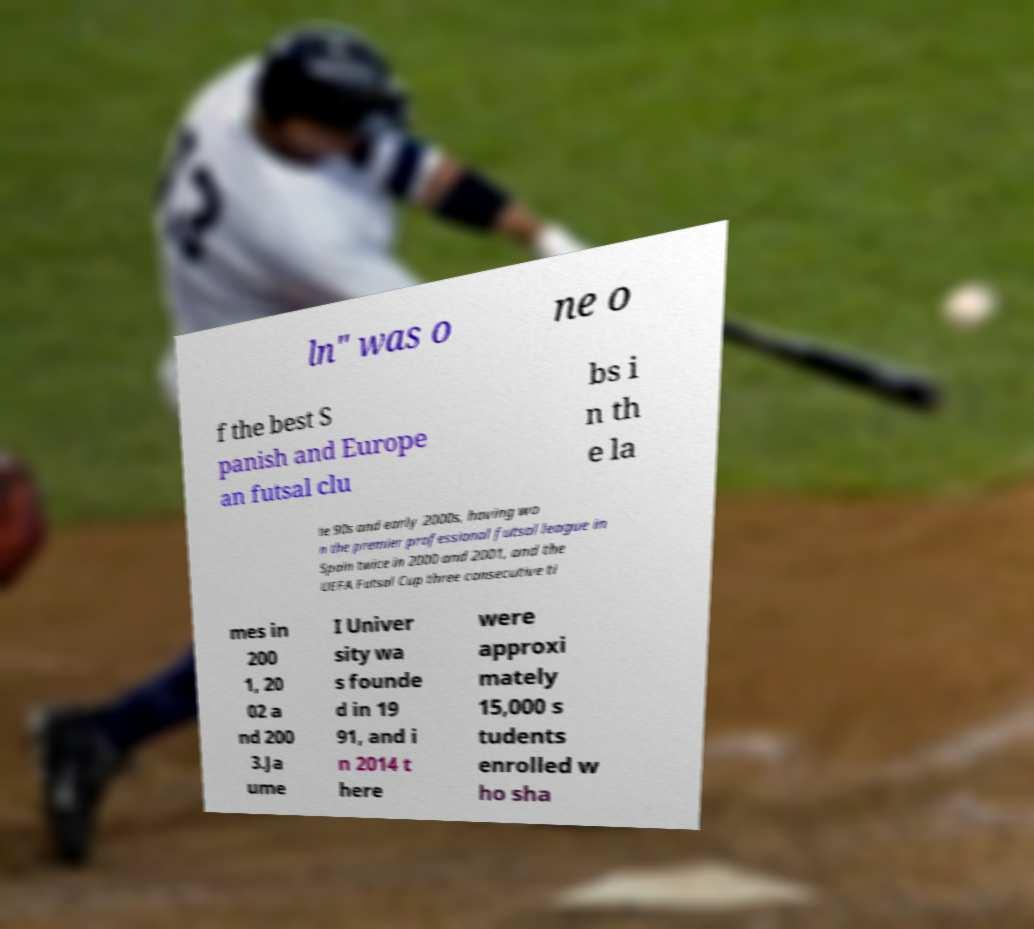Please read and relay the text visible in this image. What does it say? ln" was o ne o f the best S panish and Europe an futsal clu bs i n th e la te 90s and early 2000s, having wo n the premier professional futsal league in Spain twice in 2000 and 2001, and the UEFA Futsal Cup three consecutive ti mes in 200 1, 20 02 a nd 200 3.Ja ume I Univer sity wa s founde d in 19 91, and i n 2014 t here were approxi mately 15,000 s tudents enrolled w ho sha 